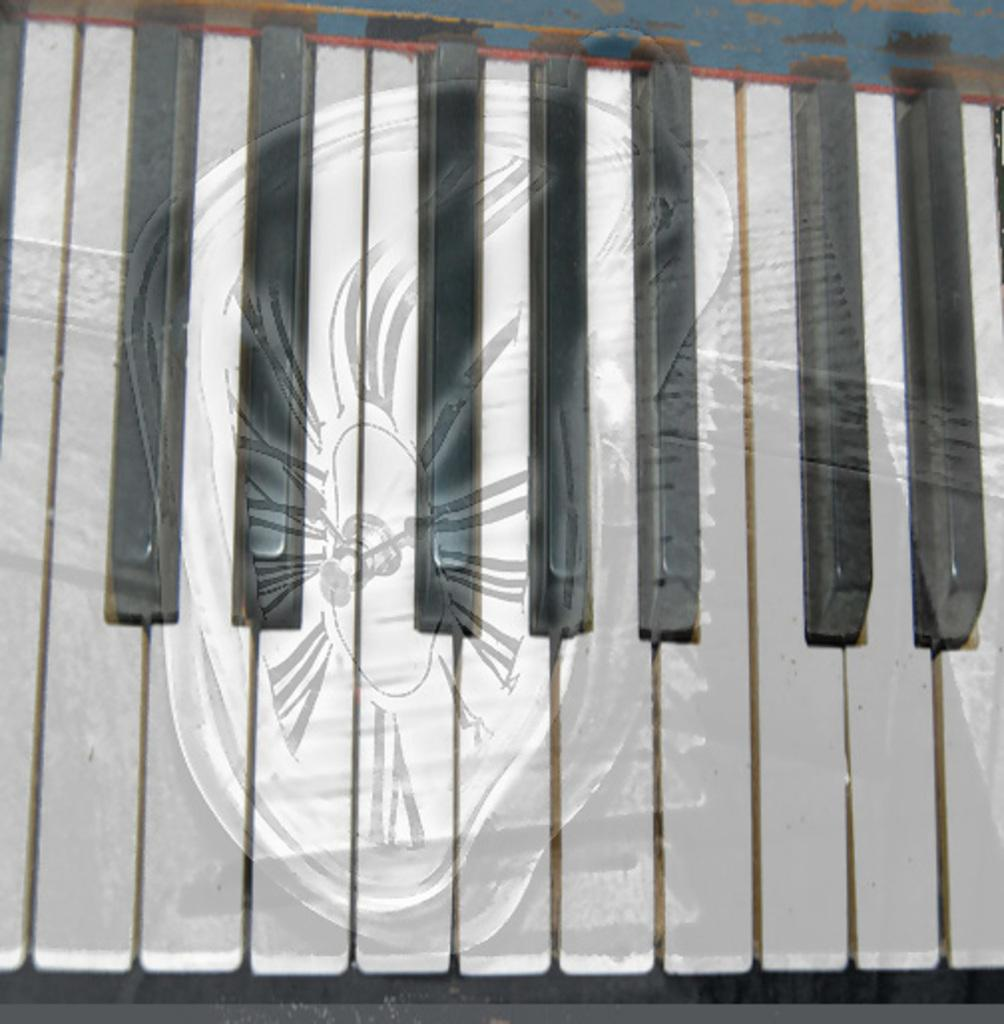What is the main object in the image? The main object in the image is a keypad of a piano or Casio. What type of device is the keypad associated with? The keypad is associated with either a piano or a Casio device. Can you describe the layout of the keypad? The layout of the keypad consists of various buttons and keys, likely for playing musical notes or other functions. What type of taste does the vase in the image have? There is no vase present in the image, so it is not possible to determine its taste. 